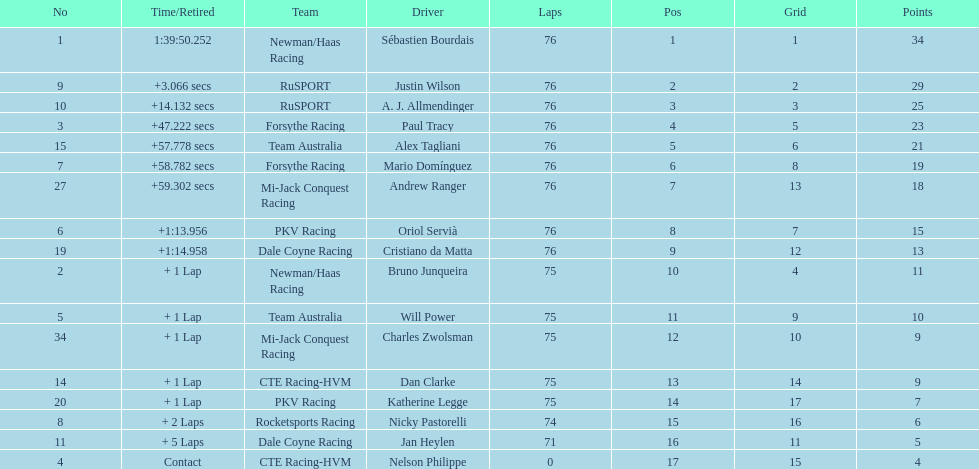Parse the table in full. {'header': ['No', 'Time/Retired', 'Team', 'Driver', 'Laps', 'Pos', 'Grid', 'Points'], 'rows': [['1', '1:39:50.252', 'Newman/Haas Racing', 'Sébastien Bourdais', '76', '1', '1', '34'], ['9', '+3.066 secs', 'RuSPORT', 'Justin Wilson', '76', '2', '2', '29'], ['10', '+14.132 secs', 'RuSPORT', 'A. J. Allmendinger', '76', '3', '3', '25'], ['3', '+47.222 secs', 'Forsythe Racing', 'Paul Tracy', '76', '4', '5', '23'], ['15', '+57.778 secs', 'Team Australia', 'Alex Tagliani', '76', '5', '6', '21'], ['7', '+58.782 secs', 'Forsythe Racing', 'Mario Domínguez', '76', '6', '8', '19'], ['27', '+59.302 secs', 'Mi-Jack Conquest Racing', 'Andrew Ranger', '76', '7', '13', '18'], ['6', '+1:13.956', 'PKV Racing', 'Oriol Servià', '76', '8', '7', '15'], ['19', '+1:14.958', 'Dale Coyne Racing', 'Cristiano da Matta', '76', '9', '12', '13'], ['2', '+ 1 Lap', 'Newman/Haas Racing', 'Bruno Junqueira', '75', '10', '4', '11'], ['5', '+ 1 Lap', 'Team Australia', 'Will Power', '75', '11', '9', '10'], ['34', '+ 1 Lap', 'Mi-Jack Conquest Racing', 'Charles Zwolsman', '75', '12', '10', '9'], ['14', '+ 1 Lap', 'CTE Racing-HVM', 'Dan Clarke', '75', '13', '14', '9'], ['20', '+ 1 Lap', 'PKV Racing', 'Katherine Legge', '75', '14', '17', '7'], ['8', '+ 2 Laps', 'Rocketsports Racing', 'Nicky Pastorelli', '74', '15', '16', '6'], ['11', '+ 5 Laps', 'Dale Coyne Racing', 'Jan Heylen', '71', '16', '11', '5'], ['4', 'Contact', 'CTE Racing-HVM', 'Nelson Philippe', '0', '17', '15', '4']]} Who was the first to finish among canadian drivers: alex tagliani or paul tracy? Paul Tracy. 